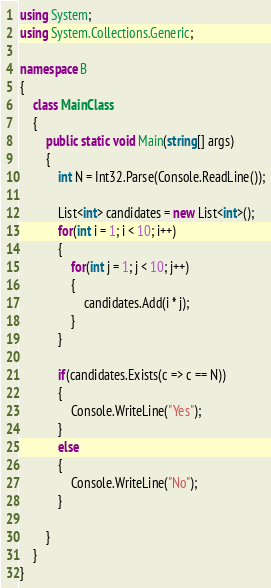Convert code to text. <code><loc_0><loc_0><loc_500><loc_500><_C#_>using System;
using System.Collections.Generic;

namespace B
{
    class MainClass
    {
        public static void Main(string[] args)
        {
            int N = Int32.Parse(Console.ReadLine());

            List<int> candidates = new List<int>();
            for(int i = 1; i < 10; i++)
            {
                for(int j = 1; j < 10; j++)
                {
                    candidates.Add(i * j);
                }
            }

            if(candidates.Exists(c => c == N))
            {
                Console.WriteLine("Yes");
            }
            else
            {
                Console.WriteLine("No");
            }

        }
    }
}
</code> 